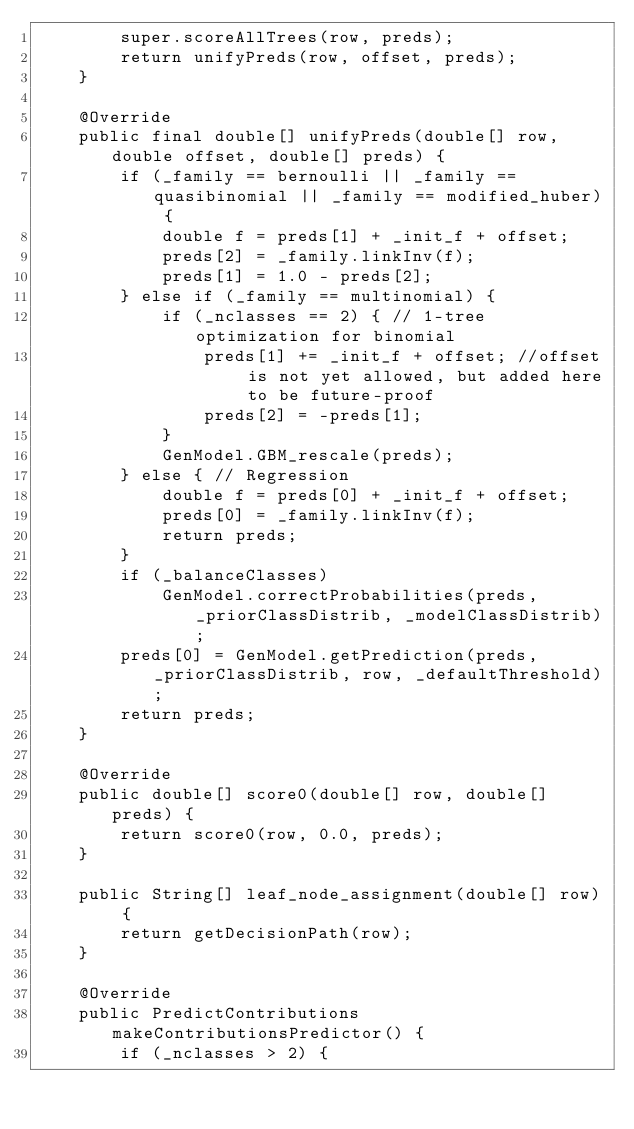Convert code to text. <code><loc_0><loc_0><loc_500><loc_500><_Java_>        super.scoreAllTrees(row, preds);
        return unifyPreds(row, offset, preds);
    }

    @Override
    public final double[] unifyPreds(double[] row, double offset, double[] preds) {
        if (_family == bernoulli || _family == quasibinomial || _family == modified_huber) {
            double f = preds[1] + _init_f + offset;
            preds[2] = _family.linkInv(f);
            preds[1] = 1.0 - preds[2];
        } else if (_family == multinomial) {
            if (_nclasses == 2) { // 1-tree optimization for binomial
                preds[1] += _init_f + offset; //offset is not yet allowed, but added here to be future-proof
                preds[2] = -preds[1];
            }
            GenModel.GBM_rescale(preds);
        } else { // Regression
            double f = preds[0] + _init_f + offset;
            preds[0] = _family.linkInv(f);
            return preds;
        }
        if (_balanceClasses)
            GenModel.correctProbabilities(preds, _priorClassDistrib, _modelClassDistrib);
        preds[0] = GenModel.getPrediction(preds, _priorClassDistrib, row, _defaultThreshold);
        return preds;
    }

    @Override
    public double[] score0(double[] row, double[] preds) {
        return score0(row, 0.0, preds);
    }

    public String[] leaf_node_assignment(double[] row) {
        return getDecisionPath(row);
    }

    @Override
    public PredictContributions makeContributionsPredictor() {
        if (_nclasses > 2) {</code> 